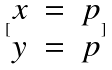Convert formula to latex. <formula><loc_0><loc_0><loc_500><loc_500>[ \begin{matrix} x & = & p \\ y & = & p \end{matrix} ]</formula> 